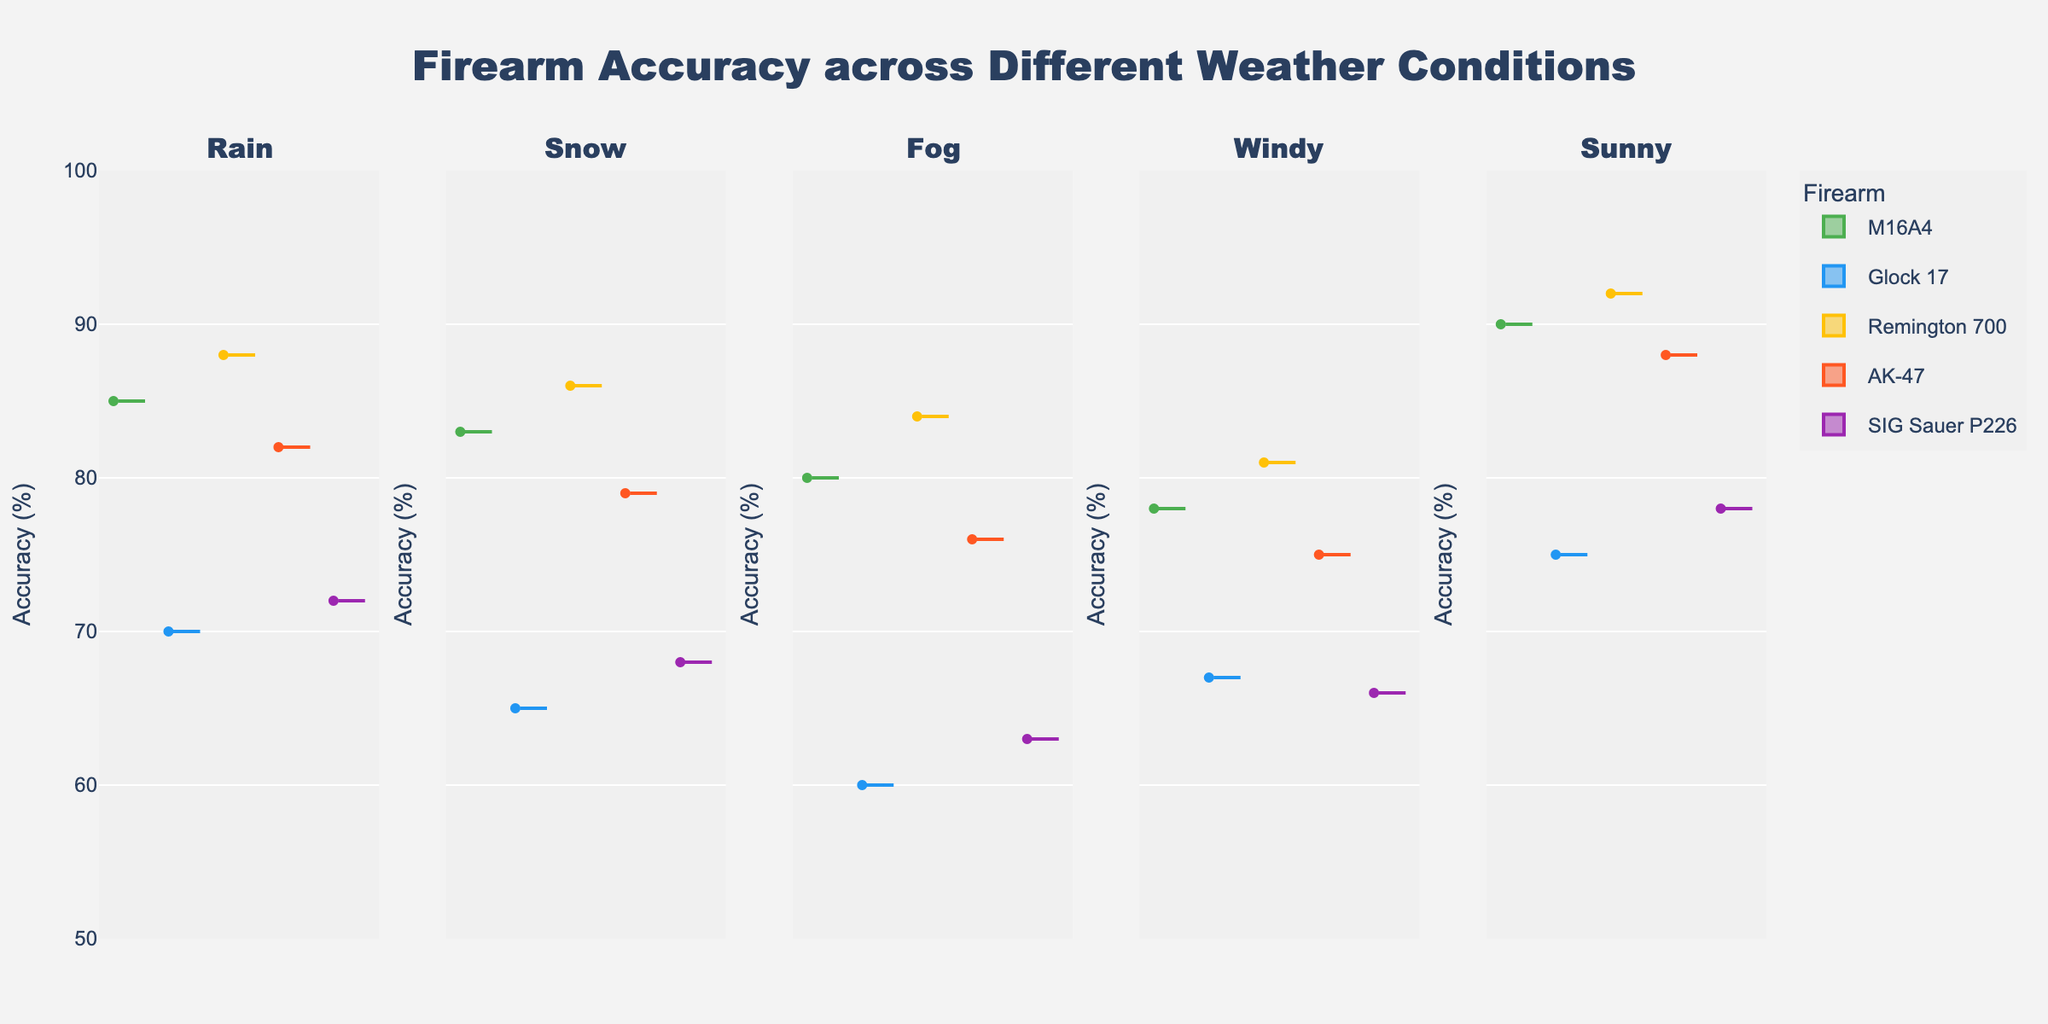What is the title of the figure? The title of the figure is located at the top and it reads "Firearm Accuracy across Different Weather Conditions".
Answer: Firearm Accuracy across Different Weather Conditions Which firearm shows the highest accuracy in sunny weather? To find the firearm with the highest accuracy, look at the violins in the 'Sunny' subplot and identify the one that has the highest central value. The Remington 700 shows the highest accuracy in sunny weather with a central value around 92%.
Answer: Remington 700 How does the average accuracy of the Glock 17 vary across different weather conditions? To determine the variation, check the central tendency (mean line or box plot center) of the Glock 17 in each weather subplot. Accuracy is around 75% in sunny, 67% in windy, 60% in fog, 65% in snow, and 70% in rain. This shows moderate variation.
Answer: Around 60% - 75% Which weather condition has the least impact on the accuracy of the M16A4? Look at the central values of the M16A4 across different weather subplots. The least variation from the central value of the M16A4 is seen in sunny conditions, where it remains quite high and stable (~90%).
Answer: Sunny Compare the accuracy of the SIG Sauer P226 in windy and snow conditions. Which condition shows better performance? Find the central values of the SIG Sauer P226 in the 'Windy' and 'Snow' subplots. In windy weather, the accuracy is around 66%, whereas in snow it's around 68%. Thus, the SIG Sauer P226 performs slightly better in snow conditions.
Answer: Snow Which firearm shows the greatest variation in accuracy across different weather conditions? To determine this, look for the firearm whose violins exhibit the widest spread (range of values) across different weather subplots. Variations seem most pronounced for the Glock 17, which shows a wide spread of accuracy values.
Answer: Glock 17 What is the median accuracy of the AK-47 in fog conditions? Check the central line of the AK-47's violin in the 'Fog' subplot. The median accuracy for AK-47 in fog conditions is around 76%.
Answer: 76% How does the accuracy of the Remington 700 compare between rainy and snowy conditions? Look at the median lines of the Remington 700 in 'Rain' and 'Snow' subplots. The accuracy in rain is about 88% and in snow, it is slightly lower at 86%.
Answer: Rain is higher Which firearm appears to be least affected by different weather conditions based on accuracy spread? Find the firearm whose violins have the least spread in each subplot. The Remington 700 consistently shows high accuracy with minimal spread, indicating it is least affected by different weather conditions.
Answer: Remington 700 What is the range of accuracy for the AK-47 in windy conditions? Observe the top and bottom of the AK-47's violin in the 'Windy' subplot. The range of accuracy for the AK-47 in windy conditions is from around 72% to 78%.
Answer: 72% - 78% 